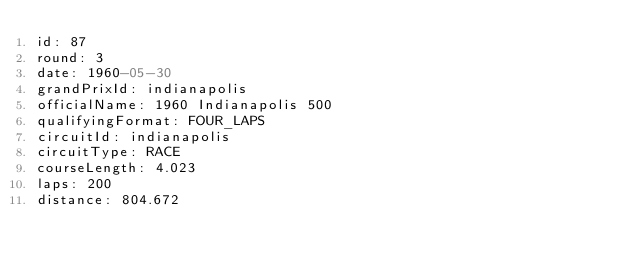Convert code to text. <code><loc_0><loc_0><loc_500><loc_500><_YAML_>id: 87
round: 3
date: 1960-05-30
grandPrixId: indianapolis
officialName: 1960 Indianapolis 500
qualifyingFormat: FOUR_LAPS
circuitId: indianapolis
circuitType: RACE
courseLength: 4.023
laps: 200
distance: 804.672
</code> 